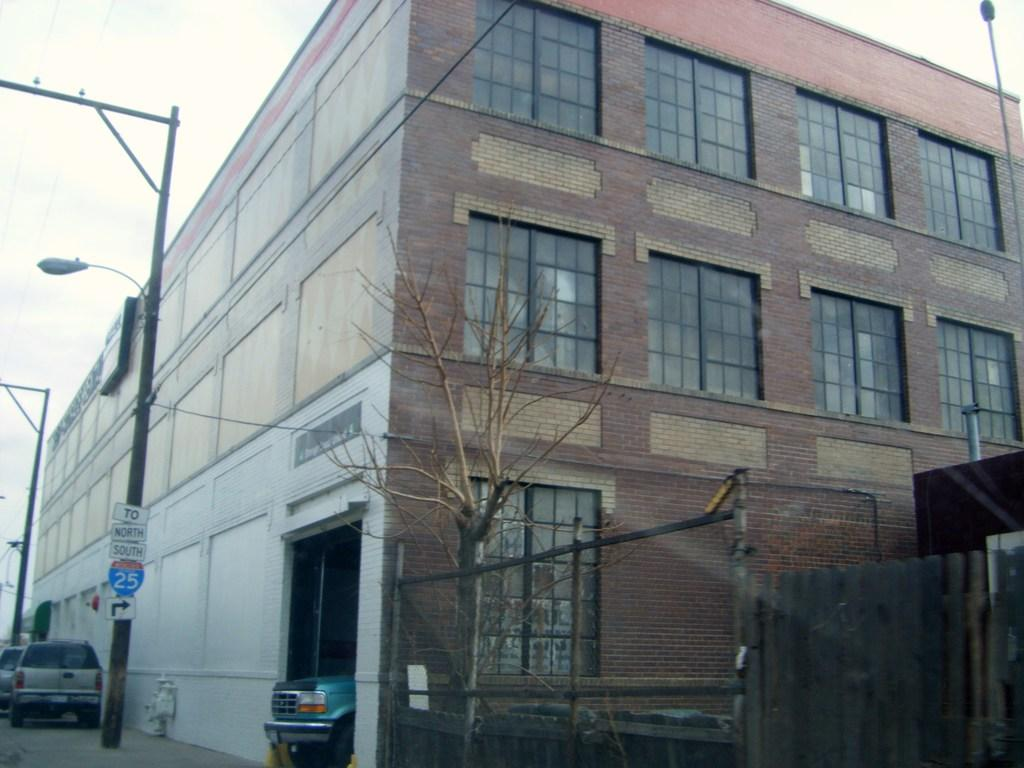What type of structure is in the image? There is a building in the image. What natural element is also present in the image? There is a tree in the image. What type of lighting is visible in the image? Street lights are visible in the image. What type of transportation is present in the image? Vehicles are present in the image. What type of barrier is in the image? There is a fence in the image. What can be seen in the background of the image? The sky is visible in the background of the image. What type of whip is being used by the authority figure in the image? There is no authority figure or whip present in the image. What type of vessel is being used to transport the vehicles in the image? There is no vessel present in the image; the vehicles are on the ground. 